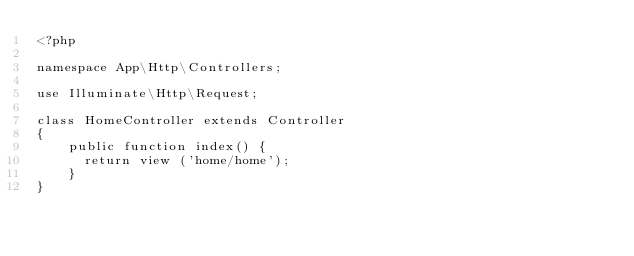<code> <loc_0><loc_0><loc_500><loc_500><_PHP_><?php

namespace App\Http\Controllers;

use Illuminate\Http\Request;

class HomeController extends Controller
{
    public function index() {
      return view ('home/home');
    }
}
</code> 